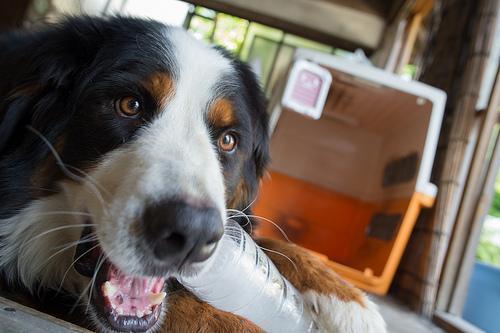How many dogs are shown?
Give a very brief answer. 1. 